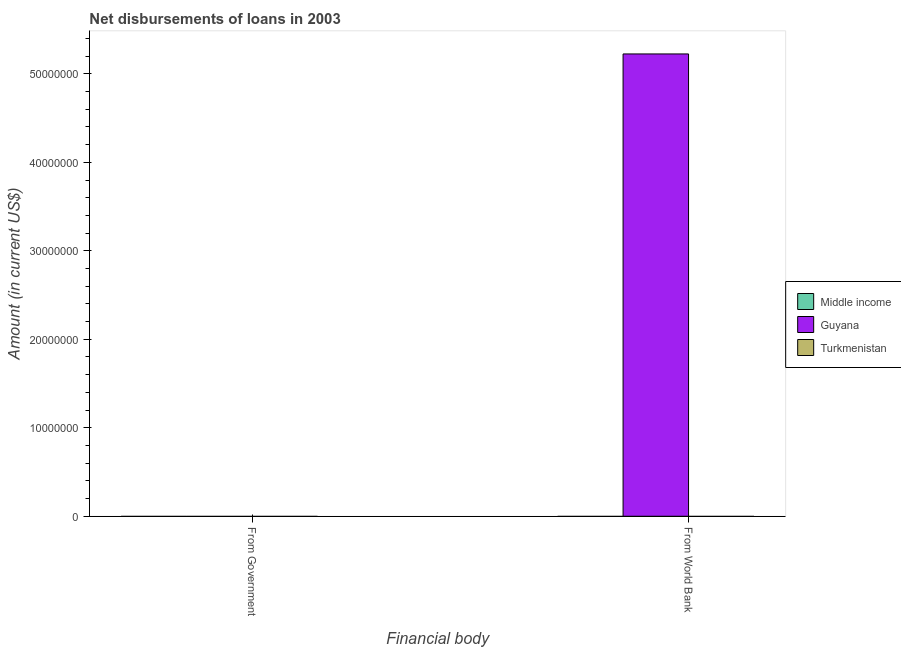How many different coloured bars are there?
Your answer should be very brief. 1. Are the number of bars on each tick of the X-axis equal?
Provide a succinct answer. No. How many bars are there on the 2nd tick from the left?
Give a very brief answer. 1. How many bars are there on the 1st tick from the right?
Provide a succinct answer. 1. What is the label of the 2nd group of bars from the left?
Offer a terse response. From World Bank. What is the net disbursements of loan from world bank in Turkmenistan?
Give a very brief answer. 0. Across all countries, what is the maximum net disbursements of loan from world bank?
Make the answer very short. 5.22e+07. In which country was the net disbursements of loan from world bank maximum?
Make the answer very short. Guyana. What is the total net disbursements of loan from world bank in the graph?
Provide a succinct answer. 5.22e+07. What is the difference between the net disbursements of loan from world bank in Turkmenistan and the net disbursements of loan from government in Middle income?
Ensure brevity in your answer.  0. What is the average net disbursements of loan from government per country?
Give a very brief answer. 0. In how many countries, is the net disbursements of loan from world bank greater than the average net disbursements of loan from world bank taken over all countries?
Ensure brevity in your answer.  1. Are all the bars in the graph horizontal?
Provide a short and direct response. No. How many countries are there in the graph?
Keep it short and to the point. 3. What is the difference between two consecutive major ticks on the Y-axis?
Ensure brevity in your answer.  1.00e+07. Are the values on the major ticks of Y-axis written in scientific E-notation?
Provide a succinct answer. No. Does the graph contain grids?
Your answer should be compact. No. Where does the legend appear in the graph?
Provide a short and direct response. Center right. What is the title of the graph?
Your answer should be compact. Net disbursements of loans in 2003. What is the label or title of the X-axis?
Ensure brevity in your answer.  Financial body. What is the label or title of the Y-axis?
Offer a terse response. Amount (in current US$). What is the Amount (in current US$) of Middle income in From Government?
Your answer should be very brief. 0. What is the Amount (in current US$) of Guyana in From Government?
Provide a short and direct response. 0. What is the Amount (in current US$) in Guyana in From World Bank?
Your answer should be very brief. 5.22e+07. Across all Financial body, what is the maximum Amount (in current US$) of Guyana?
Make the answer very short. 5.22e+07. What is the total Amount (in current US$) of Guyana in the graph?
Offer a terse response. 5.22e+07. What is the total Amount (in current US$) of Turkmenistan in the graph?
Your answer should be compact. 0. What is the average Amount (in current US$) in Middle income per Financial body?
Offer a very short reply. 0. What is the average Amount (in current US$) of Guyana per Financial body?
Your answer should be very brief. 2.61e+07. What is the average Amount (in current US$) of Turkmenistan per Financial body?
Provide a succinct answer. 0. What is the difference between the highest and the lowest Amount (in current US$) of Guyana?
Make the answer very short. 5.22e+07. 